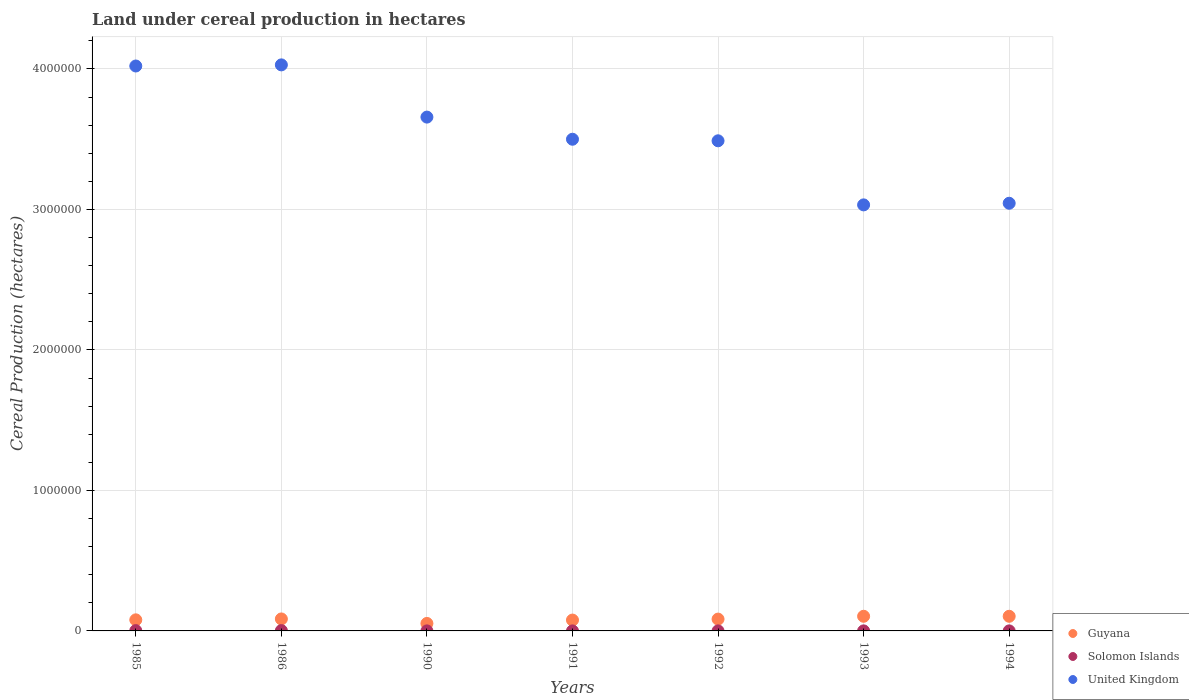What is the land under cereal production in United Kingdom in 1992?
Your answer should be compact. 3.49e+06. Across all years, what is the maximum land under cereal production in United Kingdom?
Provide a succinct answer. 4.03e+06. Across all years, what is the minimum land under cereal production in United Kingdom?
Your answer should be compact. 3.03e+06. In which year was the land under cereal production in United Kingdom minimum?
Provide a succinct answer. 1993. What is the total land under cereal production in Solomon Islands in the graph?
Your response must be concise. 5920. What is the difference between the land under cereal production in United Kingdom in 1986 and that in 1994?
Your response must be concise. 9.85e+05. What is the difference between the land under cereal production in Guyana in 1993 and the land under cereal production in Solomon Islands in 1986?
Offer a very short reply. 1.02e+05. What is the average land under cereal production in Guyana per year?
Keep it short and to the point. 8.39e+04. In the year 1994, what is the difference between the land under cereal production in United Kingdom and land under cereal production in Guyana?
Ensure brevity in your answer.  2.94e+06. What is the ratio of the land under cereal production in Solomon Islands in 1986 to that in 1992?
Offer a very short reply. 7.75. Is the land under cereal production in Solomon Islands in 1992 less than that in 1993?
Provide a succinct answer. No. What is the difference between the highest and the second highest land under cereal production in United Kingdom?
Your answer should be compact. 8000. What is the difference between the highest and the lowest land under cereal production in Solomon Islands?
Provide a succinct answer. 2131. In how many years, is the land under cereal production in Solomon Islands greater than the average land under cereal production in Solomon Islands taken over all years?
Give a very brief answer. 2. Is the land under cereal production in Solomon Islands strictly less than the land under cereal production in United Kingdom over the years?
Your answer should be very brief. Yes. How many dotlines are there?
Offer a very short reply. 3. What is the difference between two consecutive major ticks on the Y-axis?
Your response must be concise. 1.00e+06. Does the graph contain any zero values?
Your answer should be compact. No. Does the graph contain grids?
Provide a short and direct response. Yes. What is the title of the graph?
Your response must be concise. Land under cereal production in hectares. What is the label or title of the X-axis?
Your answer should be very brief. Years. What is the label or title of the Y-axis?
Keep it short and to the point. Cereal Production (hectares). What is the Cereal Production (hectares) in Guyana in 1985?
Your answer should be compact. 7.89e+04. What is the Cereal Production (hectares) of Solomon Islands in 1985?
Make the answer very short. 2170. What is the Cereal Production (hectares) in United Kingdom in 1985?
Offer a very short reply. 4.02e+06. What is the Cereal Production (hectares) of Guyana in 1986?
Offer a terse response. 8.53e+04. What is the Cereal Production (hectares) in Solomon Islands in 1986?
Provide a short and direct response. 2355. What is the Cereal Production (hectares) of United Kingdom in 1986?
Make the answer very short. 4.03e+06. What is the Cereal Production (hectares) of Guyana in 1990?
Give a very brief answer. 5.33e+04. What is the Cereal Production (hectares) of Solomon Islands in 1990?
Make the answer very short. 259. What is the Cereal Production (hectares) in United Kingdom in 1990?
Offer a terse response. 3.66e+06. What is the Cereal Production (hectares) in Guyana in 1991?
Provide a short and direct response. 7.72e+04. What is the Cereal Production (hectares) of Solomon Islands in 1991?
Your answer should be compact. 224. What is the Cereal Production (hectares) in United Kingdom in 1991?
Your answer should be very brief. 3.50e+06. What is the Cereal Production (hectares) of Guyana in 1992?
Your answer should be compact. 8.41e+04. What is the Cereal Production (hectares) in Solomon Islands in 1992?
Provide a succinct answer. 304. What is the Cereal Production (hectares) of United Kingdom in 1992?
Your answer should be compact. 3.49e+06. What is the Cereal Production (hectares) of Guyana in 1993?
Provide a short and direct response. 1.04e+05. What is the Cereal Production (hectares) in Solomon Islands in 1993?
Your answer should be compact. 297. What is the Cereal Production (hectares) in United Kingdom in 1993?
Provide a succinct answer. 3.03e+06. What is the Cereal Production (hectares) of Guyana in 1994?
Your answer should be compact. 1.04e+05. What is the Cereal Production (hectares) of Solomon Islands in 1994?
Provide a succinct answer. 311. What is the Cereal Production (hectares) in United Kingdom in 1994?
Your answer should be very brief. 3.04e+06. Across all years, what is the maximum Cereal Production (hectares) in Guyana?
Ensure brevity in your answer.  1.04e+05. Across all years, what is the maximum Cereal Production (hectares) of Solomon Islands?
Provide a short and direct response. 2355. Across all years, what is the maximum Cereal Production (hectares) in United Kingdom?
Your answer should be compact. 4.03e+06. Across all years, what is the minimum Cereal Production (hectares) in Guyana?
Provide a short and direct response. 5.33e+04. Across all years, what is the minimum Cereal Production (hectares) of Solomon Islands?
Your answer should be very brief. 224. Across all years, what is the minimum Cereal Production (hectares) of United Kingdom?
Ensure brevity in your answer.  3.03e+06. What is the total Cereal Production (hectares) in Guyana in the graph?
Provide a succinct answer. 5.87e+05. What is the total Cereal Production (hectares) of Solomon Islands in the graph?
Provide a short and direct response. 5920. What is the total Cereal Production (hectares) in United Kingdom in the graph?
Your answer should be very brief. 2.48e+07. What is the difference between the Cereal Production (hectares) in Guyana in 1985 and that in 1986?
Keep it short and to the point. -6413. What is the difference between the Cereal Production (hectares) in Solomon Islands in 1985 and that in 1986?
Your response must be concise. -185. What is the difference between the Cereal Production (hectares) in United Kingdom in 1985 and that in 1986?
Your response must be concise. -8000. What is the difference between the Cereal Production (hectares) of Guyana in 1985 and that in 1990?
Offer a very short reply. 2.56e+04. What is the difference between the Cereal Production (hectares) of Solomon Islands in 1985 and that in 1990?
Make the answer very short. 1911. What is the difference between the Cereal Production (hectares) in United Kingdom in 1985 and that in 1990?
Ensure brevity in your answer.  3.64e+05. What is the difference between the Cereal Production (hectares) in Guyana in 1985 and that in 1991?
Your answer should be very brief. 1636. What is the difference between the Cereal Production (hectares) of Solomon Islands in 1985 and that in 1991?
Keep it short and to the point. 1946. What is the difference between the Cereal Production (hectares) of United Kingdom in 1985 and that in 1991?
Give a very brief answer. 5.21e+05. What is the difference between the Cereal Production (hectares) in Guyana in 1985 and that in 1992?
Ensure brevity in your answer.  -5238. What is the difference between the Cereal Production (hectares) in Solomon Islands in 1985 and that in 1992?
Your answer should be very brief. 1866. What is the difference between the Cereal Production (hectares) of United Kingdom in 1985 and that in 1992?
Ensure brevity in your answer.  5.32e+05. What is the difference between the Cereal Production (hectares) in Guyana in 1985 and that in 1993?
Make the answer very short. -2.54e+04. What is the difference between the Cereal Production (hectares) in Solomon Islands in 1985 and that in 1993?
Provide a short and direct response. 1873. What is the difference between the Cereal Production (hectares) in United Kingdom in 1985 and that in 1993?
Give a very brief answer. 9.89e+05. What is the difference between the Cereal Production (hectares) of Guyana in 1985 and that in 1994?
Give a very brief answer. -2.53e+04. What is the difference between the Cereal Production (hectares) of Solomon Islands in 1985 and that in 1994?
Provide a succinct answer. 1859. What is the difference between the Cereal Production (hectares) of United Kingdom in 1985 and that in 1994?
Provide a short and direct response. 9.77e+05. What is the difference between the Cereal Production (hectares) of Guyana in 1986 and that in 1990?
Your answer should be very brief. 3.20e+04. What is the difference between the Cereal Production (hectares) in Solomon Islands in 1986 and that in 1990?
Ensure brevity in your answer.  2096. What is the difference between the Cereal Production (hectares) of United Kingdom in 1986 and that in 1990?
Keep it short and to the point. 3.72e+05. What is the difference between the Cereal Production (hectares) of Guyana in 1986 and that in 1991?
Provide a short and direct response. 8049. What is the difference between the Cereal Production (hectares) of Solomon Islands in 1986 and that in 1991?
Make the answer very short. 2131. What is the difference between the Cereal Production (hectares) of United Kingdom in 1986 and that in 1991?
Provide a succinct answer. 5.29e+05. What is the difference between the Cereal Production (hectares) of Guyana in 1986 and that in 1992?
Provide a short and direct response. 1175. What is the difference between the Cereal Production (hectares) in Solomon Islands in 1986 and that in 1992?
Make the answer very short. 2051. What is the difference between the Cereal Production (hectares) of United Kingdom in 1986 and that in 1992?
Keep it short and to the point. 5.40e+05. What is the difference between the Cereal Production (hectares) of Guyana in 1986 and that in 1993?
Your answer should be compact. -1.90e+04. What is the difference between the Cereal Production (hectares) in Solomon Islands in 1986 and that in 1993?
Your response must be concise. 2058. What is the difference between the Cereal Production (hectares) in United Kingdom in 1986 and that in 1993?
Offer a terse response. 9.97e+05. What is the difference between the Cereal Production (hectares) in Guyana in 1986 and that in 1994?
Ensure brevity in your answer.  -1.89e+04. What is the difference between the Cereal Production (hectares) of Solomon Islands in 1986 and that in 1994?
Offer a terse response. 2044. What is the difference between the Cereal Production (hectares) in United Kingdom in 1986 and that in 1994?
Offer a terse response. 9.85e+05. What is the difference between the Cereal Production (hectares) in Guyana in 1990 and that in 1991?
Provide a short and direct response. -2.40e+04. What is the difference between the Cereal Production (hectares) in Solomon Islands in 1990 and that in 1991?
Offer a terse response. 35. What is the difference between the Cereal Production (hectares) in United Kingdom in 1990 and that in 1991?
Make the answer very short. 1.58e+05. What is the difference between the Cereal Production (hectares) of Guyana in 1990 and that in 1992?
Your answer should be compact. -3.09e+04. What is the difference between the Cereal Production (hectares) in Solomon Islands in 1990 and that in 1992?
Give a very brief answer. -45. What is the difference between the Cereal Production (hectares) in United Kingdom in 1990 and that in 1992?
Make the answer very short. 1.69e+05. What is the difference between the Cereal Production (hectares) in Guyana in 1990 and that in 1993?
Provide a succinct answer. -5.10e+04. What is the difference between the Cereal Production (hectares) of Solomon Islands in 1990 and that in 1993?
Make the answer very short. -38. What is the difference between the Cereal Production (hectares) of United Kingdom in 1990 and that in 1993?
Your response must be concise. 6.25e+05. What is the difference between the Cereal Production (hectares) of Guyana in 1990 and that in 1994?
Your response must be concise. -5.09e+04. What is the difference between the Cereal Production (hectares) of Solomon Islands in 1990 and that in 1994?
Make the answer very short. -52. What is the difference between the Cereal Production (hectares) in United Kingdom in 1990 and that in 1994?
Your response must be concise. 6.13e+05. What is the difference between the Cereal Production (hectares) of Guyana in 1991 and that in 1992?
Your response must be concise. -6874. What is the difference between the Cereal Production (hectares) in Solomon Islands in 1991 and that in 1992?
Your answer should be compact. -80. What is the difference between the Cereal Production (hectares) of United Kingdom in 1991 and that in 1992?
Your answer should be very brief. 1.11e+04. What is the difference between the Cereal Production (hectares) of Guyana in 1991 and that in 1993?
Offer a very short reply. -2.70e+04. What is the difference between the Cereal Production (hectares) in Solomon Islands in 1991 and that in 1993?
Your answer should be very brief. -73. What is the difference between the Cereal Production (hectares) in United Kingdom in 1991 and that in 1993?
Ensure brevity in your answer.  4.67e+05. What is the difference between the Cereal Production (hectares) in Guyana in 1991 and that in 1994?
Make the answer very short. -2.69e+04. What is the difference between the Cereal Production (hectares) of Solomon Islands in 1991 and that in 1994?
Make the answer very short. -87. What is the difference between the Cereal Production (hectares) in United Kingdom in 1991 and that in 1994?
Keep it short and to the point. 4.56e+05. What is the difference between the Cereal Production (hectares) of Guyana in 1992 and that in 1993?
Offer a terse response. -2.01e+04. What is the difference between the Cereal Production (hectares) in United Kingdom in 1992 and that in 1993?
Make the answer very short. 4.56e+05. What is the difference between the Cereal Production (hectares) in Guyana in 1992 and that in 1994?
Ensure brevity in your answer.  -2.01e+04. What is the difference between the Cereal Production (hectares) of United Kingdom in 1992 and that in 1994?
Give a very brief answer. 4.45e+05. What is the difference between the Cereal Production (hectares) in Guyana in 1993 and that in 1994?
Offer a very short reply. 78. What is the difference between the Cereal Production (hectares) of Solomon Islands in 1993 and that in 1994?
Provide a short and direct response. -14. What is the difference between the Cereal Production (hectares) of United Kingdom in 1993 and that in 1994?
Provide a succinct answer. -1.15e+04. What is the difference between the Cereal Production (hectares) in Guyana in 1985 and the Cereal Production (hectares) in Solomon Islands in 1986?
Offer a very short reply. 7.65e+04. What is the difference between the Cereal Production (hectares) in Guyana in 1985 and the Cereal Production (hectares) in United Kingdom in 1986?
Your answer should be very brief. -3.95e+06. What is the difference between the Cereal Production (hectares) of Solomon Islands in 1985 and the Cereal Production (hectares) of United Kingdom in 1986?
Your response must be concise. -4.03e+06. What is the difference between the Cereal Production (hectares) in Guyana in 1985 and the Cereal Production (hectares) in Solomon Islands in 1990?
Ensure brevity in your answer.  7.86e+04. What is the difference between the Cereal Production (hectares) of Guyana in 1985 and the Cereal Production (hectares) of United Kingdom in 1990?
Provide a short and direct response. -3.58e+06. What is the difference between the Cereal Production (hectares) in Solomon Islands in 1985 and the Cereal Production (hectares) in United Kingdom in 1990?
Make the answer very short. -3.66e+06. What is the difference between the Cereal Production (hectares) in Guyana in 1985 and the Cereal Production (hectares) in Solomon Islands in 1991?
Offer a very short reply. 7.87e+04. What is the difference between the Cereal Production (hectares) in Guyana in 1985 and the Cereal Production (hectares) in United Kingdom in 1991?
Your answer should be very brief. -3.42e+06. What is the difference between the Cereal Production (hectares) in Solomon Islands in 1985 and the Cereal Production (hectares) in United Kingdom in 1991?
Ensure brevity in your answer.  -3.50e+06. What is the difference between the Cereal Production (hectares) of Guyana in 1985 and the Cereal Production (hectares) of Solomon Islands in 1992?
Keep it short and to the point. 7.86e+04. What is the difference between the Cereal Production (hectares) of Guyana in 1985 and the Cereal Production (hectares) of United Kingdom in 1992?
Offer a very short reply. -3.41e+06. What is the difference between the Cereal Production (hectares) of Solomon Islands in 1985 and the Cereal Production (hectares) of United Kingdom in 1992?
Your answer should be compact. -3.49e+06. What is the difference between the Cereal Production (hectares) of Guyana in 1985 and the Cereal Production (hectares) of Solomon Islands in 1993?
Keep it short and to the point. 7.86e+04. What is the difference between the Cereal Production (hectares) of Guyana in 1985 and the Cereal Production (hectares) of United Kingdom in 1993?
Your answer should be very brief. -2.95e+06. What is the difference between the Cereal Production (hectares) in Solomon Islands in 1985 and the Cereal Production (hectares) in United Kingdom in 1993?
Offer a terse response. -3.03e+06. What is the difference between the Cereal Production (hectares) of Guyana in 1985 and the Cereal Production (hectares) of Solomon Islands in 1994?
Your response must be concise. 7.86e+04. What is the difference between the Cereal Production (hectares) of Guyana in 1985 and the Cereal Production (hectares) of United Kingdom in 1994?
Your answer should be compact. -2.97e+06. What is the difference between the Cereal Production (hectares) in Solomon Islands in 1985 and the Cereal Production (hectares) in United Kingdom in 1994?
Make the answer very short. -3.04e+06. What is the difference between the Cereal Production (hectares) of Guyana in 1986 and the Cereal Production (hectares) of Solomon Islands in 1990?
Ensure brevity in your answer.  8.50e+04. What is the difference between the Cereal Production (hectares) in Guyana in 1986 and the Cereal Production (hectares) in United Kingdom in 1990?
Your response must be concise. -3.57e+06. What is the difference between the Cereal Production (hectares) in Solomon Islands in 1986 and the Cereal Production (hectares) in United Kingdom in 1990?
Offer a very short reply. -3.65e+06. What is the difference between the Cereal Production (hectares) of Guyana in 1986 and the Cereal Production (hectares) of Solomon Islands in 1991?
Offer a terse response. 8.51e+04. What is the difference between the Cereal Production (hectares) of Guyana in 1986 and the Cereal Production (hectares) of United Kingdom in 1991?
Your answer should be compact. -3.41e+06. What is the difference between the Cereal Production (hectares) of Solomon Islands in 1986 and the Cereal Production (hectares) of United Kingdom in 1991?
Make the answer very short. -3.50e+06. What is the difference between the Cereal Production (hectares) in Guyana in 1986 and the Cereal Production (hectares) in Solomon Islands in 1992?
Your response must be concise. 8.50e+04. What is the difference between the Cereal Production (hectares) in Guyana in 1986 and the Cereal Production (hectares) in United Kingdom in 1992?
Make the answer very short. -3.40e+06. What is the difference between the Cereal Production (hectares) in Solomon Islands in 1986 and the Cereal Production (hectares) in United Kingdom in 1992?
Ensure brevity in your answer.  -3.49e+06. What is the difference between the Cereal Production (hectares) in Guyana in 1986 and the Cereal Production (hectares) in Solomon Islands in 1993?
Your answer should be very brief. 8.50e+04. What is the difference between the Cereal Production (hectares) in Guyana in 1986 and the Cereal Production (hectares) in United Kingdom in 1993?
Ensure brevity in your answer.  -2.95e+06. What is the difference between the Cereal Production (hectares) in Solomon Islands in 1986 and the Cereal Production (hectares) in United Kingdom in 1993?
Provide a succinct answer. -3.03e+06. What is the difference between the Cereal Production (hectares) in Guyana in 1986 and the Cereal Production (hectares) in Solomon Islands in 1994?
Your answer should be compact. 8.50e+04. What is the difference between the Cereal Production (hectares) of Guyana in 1986 and the Cereal Production (hectares) of United Kingdom in 1994?
Your answer should be very brief. -2.96e+06. What is the difference between the Cereal Production (hectares) of Solomon Islands in 1986 and the Cereal Production (hectares) of United Kingdom in 1994?
Ensure brevity in your answer.  -3.04e+06. What is the difference between the Cereal Production (hectares) of Guyana in 1990 and the Cereal Production (hectares) of Solomon Islands in 1991?
Make the answer very short. 5.30e+04. What is the difference between the Cereal Production (hectares) in Guyana in 1990 and the Cereal Production (hectares) in United Kingdom in 1991?
Make the answer very short. -3.45e+06. What is the difference between the Cereal Production (hectares) of Solomon Islands in 1990 and the Cereal Production (hectares) of United Kingdom in 1991?
Your response must be concise. -3.50e+06. What is the difference between the Cereal Production (hectares) in Guyana in 1990 and the Cereal Production (hectares) in Solomon Islands in 1992?
Provide a succinct answer. 5.30e+04. What is the difference between the Cereal Production (hectares) of Guyana in 1990 and the Cereal Production (hectares) of United Kingdom in 1992?
Your answer should be compact. -3.44e+06. What is the difference between the Cereal Production (hectares) in Solomon Islands in 1990 and the Cereal Production (hectares) in United Kingdom in 1992?
Your response must be concise. -3.49e+06. What is the difference between the Cereal Production (hectares) of Guyana in 1990 and the Cereal Production (hectares) of Solomon Islands in 1993?
Your answer should be very brief. 5.30e+04. What is the difference between the Cereal Production (hectares) of Guyana in 1990 and the Cereal Production (hectares) of United Kingdom in 1993?
Keep it short and to the point. -2.98e+06. What is the difference between the Cereal Production (hectares) of Solomon Islands in 1990 and the Cereal Production (hectares) of United Kingdom in 1993?
Offer a terse response. -3.03e+06. What is the difference between the Cereal Production (hectares) of Guyana in 1990 and the Cereal Production (hectares) of Solomon Islands in 1994?
Your answer should be very brief. 5.30e+04. What is the difference between the Cereal Production (hectares) in Guyana in 1990 and the Cereal Production (hectares) in United Kingdom in 1994?
Make the answer very short. -2.99e+06. What is the difference between the Cereal Production (hectares) of Solomon Islands in 1990 and the Cereal Production (hectares) of United Kingdom in 1994?
Offer a very short reply. -3.04e+06. What is the difference between the Cereal Production (hectares) in Guyana in 1991 and the Cereal Production (hectares) in Solomon Islands in 1992?
Give a very brief answer. 7.69e+04. What is the difference between the Cereal Production (hectares) in Guyana in 1991 and the Cereal Production (hectares) in United Kingdom in 1992?
Keep it short and to the point. -3.41e+06. What is the difference between the Cereal Production (hectares) of Solomon Islands in 1991 and the Cereal Production (hectares) of United Kingdom in 1992?
Keep it short and to the point. -3.49e+06. What is the difference between the Cereal Production (hectares) of Guyana in 1991 and the Cereal Production (hectares) of Solomon Islands in 1993?
Make the answer very short. 7.69e+04. What is the difference between the Cereal Production (hectares) in Guyana in 1991 and the Cereal Production (hectares) in United Kingdom in 1993?
Provide a succinct answer. -2.96e+06. What is the difference between the Cereal Production (hectares) of Solomon Islands in 1991 and the Cereal Production (hectares) of United Kingdom in 1993?
Offer a very short reply. -3.03e+06. What is the difference between the Cereal Production (hectares) of Guyana in 1991 and the Cereal Production (hectares) of Solomon Islands in 1994?
Your answer should be compact. 7.69e+04. What is the difference between the Cereal Production (hectares) in Guyana in 1991 and the Cereal Production (hectares) in United Kingdom in 1994?
Make the answer very short. -2.97e+06. What is the difference between the Cereal Production (hectares) in Solomon Islands in 1991 and the Cereal Production (hectares) in United Kingdom in 1994?
Your answer should be compact. -3.04e+06. What is the difference between the Cereal Production (hectares) in Guyana in 1992 and the Cereal Production (hectares) in Solomon Islands in 1993?
Offer a very short reply. 8.38e+04. What is the difference between the Cereal Production (hectares) of Guyana in 1992 and the Cereal Production (hectares) of United Kingdom in 1993?
Provide a short and direct response. -2.95e+06. What is the difference between the Cereal Production (hectares) in Solomon Islands in 1992 and the Cereal Production (hectares) in United Kingdom in 1993?
Provide a short and direct response. -3.03e+06. What is the difference between the Cereal Production (hectares) of Guyana in 1992 and the Cereal Production (hectares) of Solomon Islands in 1994?
Ensure brevity in your answer.  8.38e+04. What is the difference between the Cereal Production (hectares) of Guyana in 1992 and the Cereal Production (hectares) of United Kingdom in 1994?
Give a very brief answer. -2.96e+06. What is the difference between the Cereal Production (hectares) in Solomon Islands in 1992 and the Cereal Production (hectares) in United Kingdom in 1994?
Offer a very short reply. -3.04e+06. What is the difference between the Cereal Production (hectares) in Guyana in 1993 and the Cereal Production (hectares) in Solomon Islands in 1994?
Provide a succinct answer. 1.04e+05. What is the difference between the Cereal Production (hectares) in Guyana in 1993 and the Cereal Production (hectares) in United Kingdom in 1994?
Make the answer very short. -2.94e+06. What is the difference between the Cereal Production (hectares) of Solomon Islands in 1993 and the Cereal Production (hectares) of United Kingdom in 1994?
Your response must be concise. -3.04e+06. What is the average Cereal Production (hectares) in Guyana per year?
Provide a succinct answer. 8.39e+04. What is the average Cereal Production (hectares) of Solomon Islands per year?
Your response must be concise. 845.71. What is the average Cereal Production (hectares) in United Kingdom per year?
Your answer should be very brief. 3.54e+06. In the year 1985, what is the difference between the Cereal Production (hectares) of Guyana and Cereal Production (hectares) of Solomon Islands?
Keep it short and to the point. 7.67e+04. In the year 1985, what is the difference between the Cereal Production (hectares) in Guyana and Cereal Production (hectares) in United Kingdom?
Offer a terse response. -3.94e+06. In the year 1985, what is the difference between the Cereal Production (hectares) in Solomon Islands and Cereal Production (hectares) in United Kingdom?
Give a very brief answer. -4.02e+06. In the year 1986, what is the difference between the Cereal Production (hectares) of Guyana and Cereal Production (hectares) of Solomon Islands?
Make the answer very short. 8.29e+04. In the year 1986, what is the difference between the Cereal Production (hectares) in Guyana and Cereal Production (hectares) in United Kingdom?
Give a very brief answer. -3.94e+06. In the year 1986, what is the difference between the Cereal Production (hectares) of Solomon Islands and Cereal Production (hectares) of United Kingdom?
Offer a terse response. -4.03e+06. In the year 1990, what is the difference between the Cereal Production (hectares) of Guyana and Cereal Production (hectares) of Solomon Islands?
Offer a very short reply. 5.30e+04. In the year 1990, what is the difference between the Cereal Production (hectares) in Guyana and Cereal Production (hectares) in United Kingdom?
Offer a very short reply. -3.60e+06. In the year 1990, what is the difference between the Cereal Production (hectares) of Solomon Islands and Cereal Production (hectares) of United Kingdom?
Provide a short and direct response. -3.66e+06. In the year 1991, what is the difference between the Cereal Production (hectares) of Guyana and Cereal Production (hectares) of Solomon Islands?
Your response must be concise. 7.70e+04. In the year 1991, what is the difference between the Cereal Production (hectares) in Guyana and Cereal Production (hectares) in United Kingdom?
Your response must be concise. -3.42e+06. In the year 1991, what is the difference between the Cereal Production (hectares) in Solomon Islands and Cereal Production (hectares) in United Kingdom?
Your response must be concise. -3.50e+06. In the year 1992, what is the difference between the Cereal Production (hectares) in Guyana and Cereal Production (hectares) in Solomon Islands?
Give a very brief answer. 8.38e+04. In the year 1992, what is the difference between the Cereal Production (hectares) in Guyana and Cereal Production (hectares) in United Kingdom?
Provide a short and direct response. -3.40e+06. In the year 1992, what is the difference between the Cereal Production (hectares) in Solomon Islands and Cereal Production (hectares) in United Kingdom?
Provide a succinct answer. -3.49e+06. In the year 1993, what is the difference between the Cereal Production (hectares) of Guyana and Cereal Production (hectares) of Solomon Islands?
Ensure brevity in your answer.  1.04e+05. In the year 1993, what is the difference between the Cereal Production (hectares) of Guyana and Cereal Production (hectares) of United Kingdom?
Make the answer very short. -2.93e+06. In the year 1993, what is the difference between the Cereal Production (hectares) of Solomon Islands and Cereal Production (hectares) of United Kingdom?
Keep it short and to the point. -3.03e+06. In the year 1994, what is the difference between the Cereal Production (hectares) of Guyana and Cereal Production (hectares) of Solomon Islands?
Provide a short and direct response. 1.04e+05. In the year 1994, what is the difference between the Cereal Production (hectares) of Guyana and Cereal Production (hectares) of United Kingdom?
Offer a terse response. -2.94e+06. In the year 1994, what is the difference between the Cereal Production (hectares) in Solomon Islands and Cereal Production (hectares) in United Kingdom?
Your answer should be compact. -3.04e+06. What is the ratio of the Cereal Production (hectares) of Guyana in 1985 to that in 1986?
Your response must be concise. 0.92. What is the ratio of the Cereal Production (hectares) in Solomon Islands in 1985 to that in 1986?
Your response must be concise. 0.92. What is the ratio of the Cereal Production (hectares) of Guyana in 1985 to that in 1990?
Keep it short and to the point. 1.48. What is the ratio of the Cereal Production (hectares) in Solomon Islands in 1985 to that in 1990?
Your answer should be very brief. 8.38. What is the ratio of the Cereal Production (hectares) in United Kingdom in 1985 to that in 1990?
Keep it short and to the point. 1.1. What is the ratio of the Cereal Production (hectares) in Guyana in 1985 to that in 1991?
Give a very brief answer. 1.02. What is the ratio of the Cereal Production (hectares) in Solomon Islands in 1985 to that in 1991?
Give a very brief answer. 9.69. What is the ratio of the Cereal Production (hectares) in United Kingdom in 1985 to that in 1991?
Provide a short and direct response. 1.15. What is the ratio of the Cereal Production (hectares) of Guyana in 1985 to that in 1992?
Give a very brief answer. 0.94. What is the ratio of the Cereal Production (hectares) in Solomon Islands in 1985 to that in 1992?
Your response must be concise. 7.14. What is the ratio of the Cereal Production (hectares) of United Kingdom in 1985 to that in 1992?
Provide a short and direct response. 1.15. What is the ratio of the Cereal Production (hectares) in Guyana in 1985 to that in 1993?
Make the answer very short. 0.76. What is the ratio of the Cereal Production (hectares) in Solomon Islands in 1985 to that in 1993?
Your response must be concise. 7.31. What is the ratio of the Cereal Production (hectares) in United Kingdom in 1985 to that in 1993?
Offer a terse response. 1.33. What is the ratio of the Cereal Production (hectares) in Guyana in 1985 to that in 1994?
Provide a succinct answer. 0.76. What is the ratio of the Cereal Production (hectares) of Solomon Islands in 1985 to that in 1994?
Give a very brief answer. 6.98. What is the ratio of the Cereal Production (hectares) in United Kingdom in 1985 to that in 1994?
Offer a terse response. 1.32. What is the ratio of the Cereal Production (hectares) of Guyana in 1986 to that in 1990?
Provide a short and direct response. 1.6. What is the ratio of the Cereal Production (hectares) in Solomon Islands in 1986 to that in 1990?
Ensure brevity in your answer.  9.09. What is the ratio of the Cereal Production (hectares) in United Kingdom in 1986 to that in 1990?
Offer a very short reply. 1.1. What is the ratio of the Cereal Production (hectares) of Guyana in 1986 to that in 1991?
Your answer should be compact. 1.1. What is the ratio of the Cereal Production (hectares) in Solomon Islands in 1986 to that in 1991?
Your answer should be very brief. 10.51. What is the ratio of the Cereal Production (hectares) of United Kingdom in 1986 to that in 1991?
Make the answer very short. 1.15. What is the ratio of the Cereal Production (hectares) in Solomon Islands in 1986 to that in 1992?
Provide a succinct answer. 7.75. What is the ratio of the Cereal Production (hectares) of United Kingdom in 1986 to that in 1992?
Ensure brevity in your answer.  1.15. What is the ratio of the Cereal Production (hectares) of Guyana in 1986 to that in 1993?
Your answer should be compact. 0.82. What is the ratio of the Cereal Production (hectares) of Solomon Islands in 1986 to that in 1993?
Ensure brevity in your answer.  7.93. What is the ratio of the Cereal Production (hectares) of United Kingdom in 1986 to that in 1993?
Keep it short and to the point. 1.33. What is the ratio of the Cereal Production (hectares) in Guyana in 1986 to that in 1994?
Keep it short and to the point. 0.82. What is the ratio of the Cereal Production (hectares) in Solomon Islands in 1986 to that in 1994?
Your response must be concise. 7.57. What is the ratio of the Cereal Production (hectares) in United Kingdom in 1986 to that in 1994?
Offer a very short reply. 1.32. What is the ratio of the Cereal Production (hectares) in Guyana in 1990 to that in 1991?
Your answer should be compact. 0.69. What is the ratio of the Cereal Production (hectares) of Solomon Islands in 1990 to that in 1991?
Offer a very short reply. 1.16. What is the ratio of the Cereal Production (hectares) of United Kingdom in 1990 to that in 1991?
Offer a very short reply. 1.04. What is the ratio of the Cereal Production (hectares) of Guyana in 1990 to that in 1992?
Make the answer very short. 0.63. What is the ratio of the Cereal Production (hectares) of Solomon Islands in 1990 to that in 1992?
Offer a very short reply. 0.85. What is the ratio of the Cereal Production (hectares) of United Kingdom in 1990 to that in 1992?
Provide a short and direct response. 1.05. What is the ratio of the Cereal Production (hectares) in Guyana in 1990 to that in 1993?
Your response must be concise. 0.51. What is the ratio of the Cereal Production (hectares) of Solomon Islands in 1990 to that in 1993?
Offer a very short reply. 0.87. What is the ratio of the Cereal Production (hectares) in United Kingdom in 1990 to that in 1993?
Your answer should be very brief. 1.21. What is the ratio of the Cereal Production (hectares) of Guyana in 1990 to that in 1994?
Offer a very short reply. 0.51. What is the ratio of the Cereal Production (hectares) in Solomon Islands in 1990 to that in 1994?
Keep it short and to the point. 0.83. What is the ratio of the Cereal Production (hectares) of United Kingdom in 1990 to that in 1994?
Your answer should be very brief. 1.2. What is the ratio of the Cereal Production (hectares) of Guyana in 1991 to that in 1992?
Your answer should be compact. 0.92. What is the ratio of the Cereal Production (hectares) of Solomon Islands in 1991 to that in 1992?
Provide a succinct answer. 0.74. What is the ratio of the Cereal Production (hectares) of Guyana in 1991 to that in 1993?
Offer a very short reply. 0.74. What is the ratio of the Cereal Production (hectares) of Solomon Islands in 1991 to that in 1993?
Your response must be concise. 0.75. What is the ratio of the Cereal Production (hectares) in United Kingdom in 1991 to that in 1993?
Keep it short and to the point. 1.15. What is the ratio of the Cereal Production (hectares) of Guyana in 1991 to that in 1994?
Give a very brief answer. 0.74. What is the ratio of the Cereal Production (hectares) in Solomon Islands in 1991 to that in 1994?
Your answer should be very brief. 0.72. What is the ratio of the Cereal Production (hectares) in United Kingdom in 1991 to that in 1994?
Offer a terse response. 1.15. What is the ratio of the Cereal Production (hectares) of Guyana in 1992 to that in 1993?
Your answer should be compact. 0.81. What is the ratio of the Cereal Production (hectares) of Solomon Islands in 1992 to that in 1993?
Give a very brief answer. 1.02. What is the ratio of the Cereal Production (hectares) of United Kingdom in 1992 to that in 1993?
Your response must be concise. 1.15. What is the ratio of the Cereal Production (hectares) in Guyana in 1992 to that in 1994?
Provide a short and direct response. 0.81. What is the ratio of the Cereal Production (hectares) in Solomon Islands in 1992 to that in 1994?
Offer a terse response. 0.98. What is the ratio of the Cereal Production (hectares) of United Kingdom in 1992 to that in 1994?
Your answer should be compact. 1.15. What is the ratio of the Cereal Production (hectares) of Guyana in 1993 to that in 1994?
Provide a short and direct response. 1. What is the ratio of the Cereal Production (hectares) of Solomon Islands in 1993 to that in 1994?
Give a very brief answer. 0.95. What is the ratio of the Cereal Production (hectares) of United Kingdom in 1993 to that in 1994?
Provide a short and direct response. 1. What is the difference between the highest and the second highest Cereal Production (hectares) in Guyana?
Give a very brief answer. 78. What is the difference between the highest and the second highest Cereal Production (hectares) of Solomon Islands?
Ensure brevity in your answer.  185. What is the difference between the highest and the second highest Cereal Production (hectares) of United Kingdom?
Offer a very short reply. 8000. What is the difference between the highest and the lowest Cereal Production (hectares) of Guyana?
Your answer should be compact. 5.10e+04. What is the difference between the highest and the lowest Cereal Production (hectares) in Solomon Islands?
Your answer should be very brief. 2131. What is the difference between the highest and the lowest Cereal Production (hectares) in United Kingdom?
Your answer should be compact. 9.97e+05. 